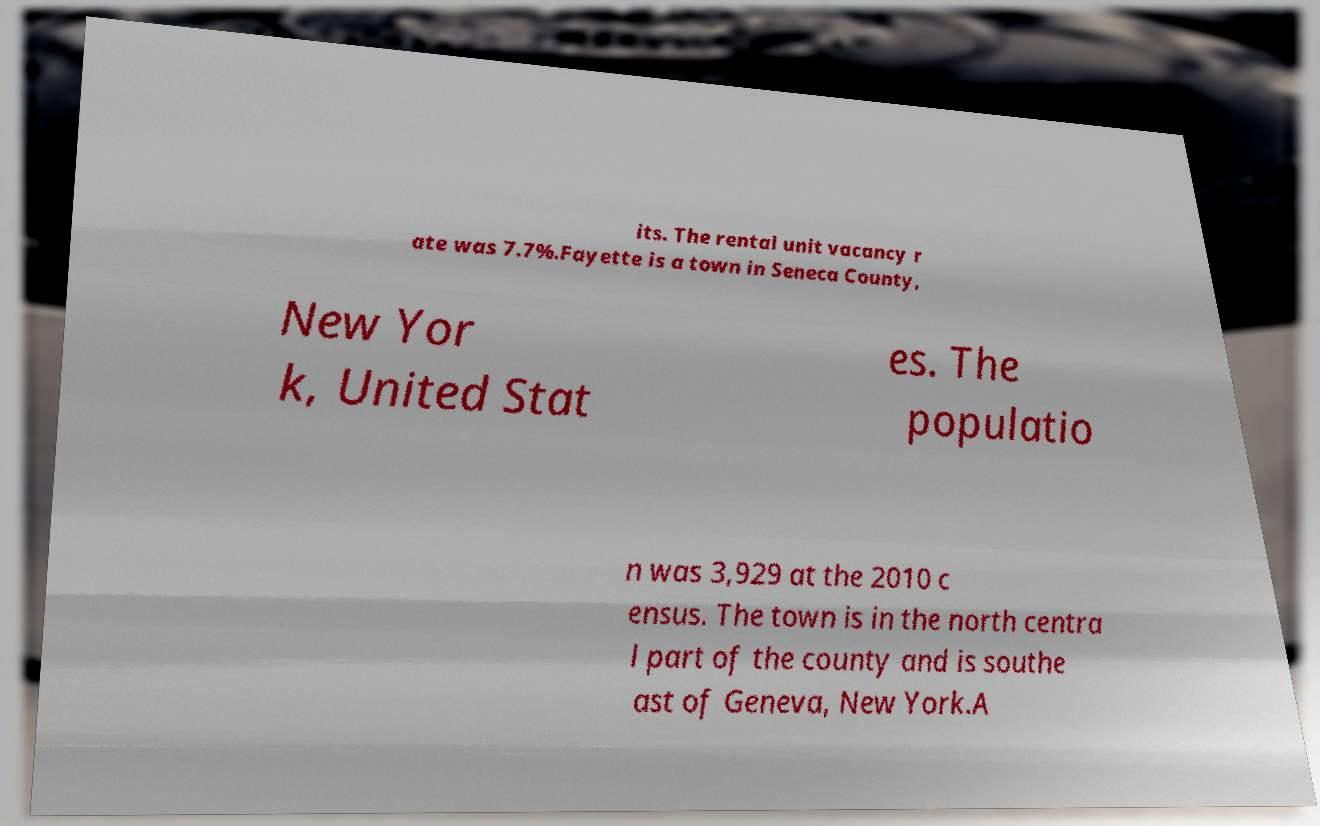Please identify and transcribe the text found in this image. its. The rental unit vacancy r ate was 7.7%.Fayette is a town in Seneca County, New Yor k, United Stat es. The populatio n was 3,929 at the 2010 c ensus. The town is in the north centra l part of the county and is southe ast of Geneva, New York.A 